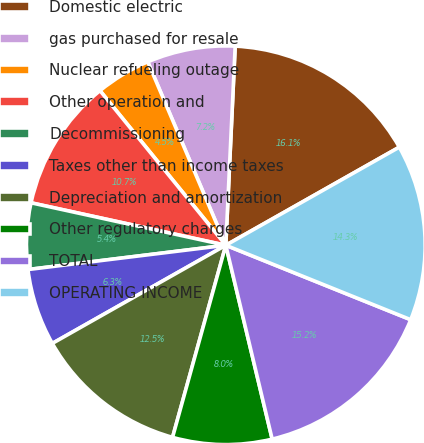Convert chart to OTSL. <chart><loc_0><loc_0><loc_500><loc_500><pie_chart><fcel>Domestic electric<fcel>gas purchased for resale<fcel>Nuclear refueling outage<fcel>Other operation and<fcel>Decommissioning<fcel>Taxes other than income taxes<fcel>Depreciation and amortization<fcel>Other regulatory charges<fcel>TOTAL<fcel>OPERATING INCOME<nl><fcel>16.06%<fcel>7.15%<fcel>4.47%<fcel>10.71%<fcel>5.36%<fcel>6.25%<fcel>12.5%<fcel>8.04%<fcel>15.17%<fcel>14.28%<nl></chart> 